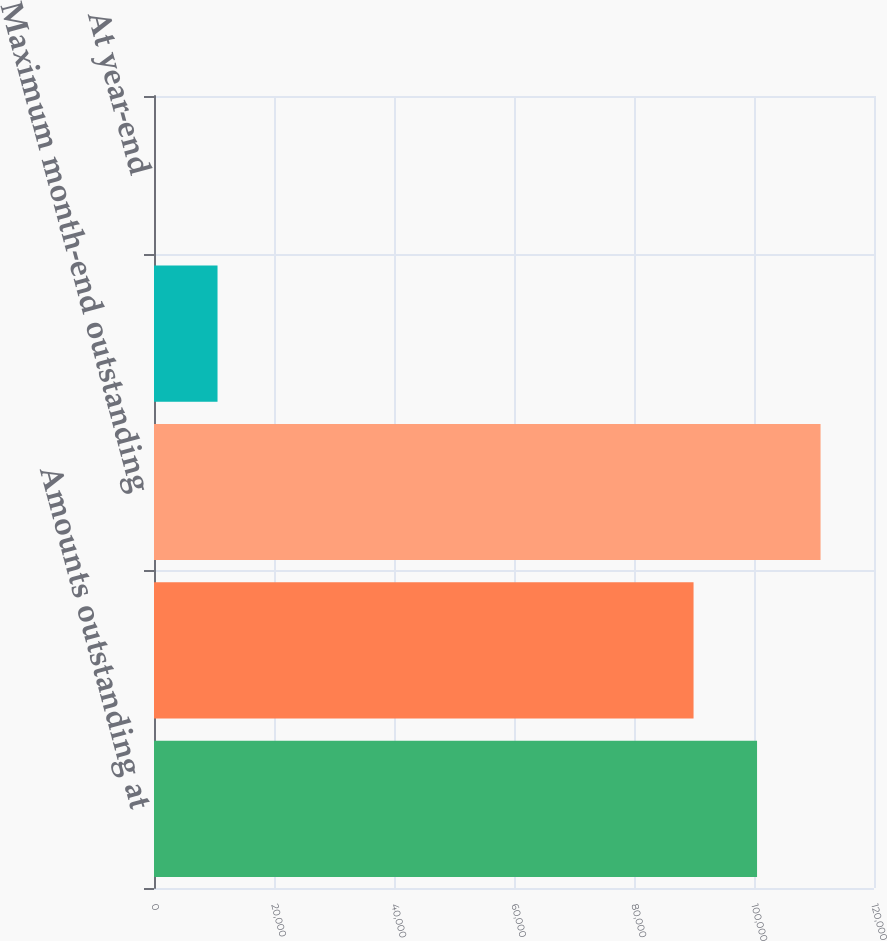<chart> <loc_0><loc_0><loc_500><loc_500><bar_chart><fcel>Amounts outstanding at<fcel>Average outstanding during the<fcel>Maximum month-end outstanding<fcel>During the year<fcel>At year-end<nl><fcel>100508<fcel>89924<fcel>111092<fcel>10587.3<fcel>3.11<nl></chart> 